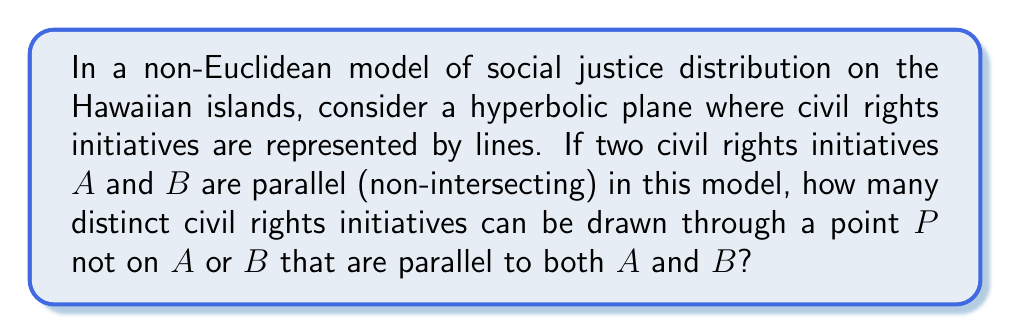Can you answer this question? Let's approach this step-by-step:

1) In Euclidean geometry, the parallel postulate states that through a point not on a given line, there is exactly one line parallel to the given line.

2) However, in hyperbolic geometry, this postulate doesn't hold. Instead, through a point not on a given line, there are infinitely many lines parallel to the given line.

3) In our social justice model, civil rights initiatives are represented as lines in a hyperbolic plane. This means that through any point $P$ not on a given initiative (line) $A$, there are infinitely many initiatives parallel to $A$.

4) Now, we're asked about initiatives parallel to both $A$ and $B$. In hyperbolic geometry, if two lines are parallel, they have a common perpendicular.

5) Let's call the common perpendicular of $A$ and $B$ as line $l$. Point $P$ must lie on one side of $l$.

6) The set of lines through $P$ parallel to $A$ forms a "fan" bounded by two limit rays. The same is true for lines parallel to $B$.

7) The intersection of these two "fans" gives us the set of lines through $P$ parallel to both $A$ and $B$.

8) In hyperbolic geometry, this intersection is always non-empty and consists of infinitely many lines.

[asy]
import geometry;

size(200);

pair A1 = (-5,1), A2 = (5,1);
pair B1 = (-5,-1), B2 = (5,-1);
pair P = (0,3);

draw(A1--A2, blue);
draw(B1--B2, red);
dot(P);

real t = 0.3;
while (t < 1) {
  draw(P--(5,1+2*t), dashed+green);
  t += 0.1;
}

label("$A$", A2, E);
label("$B$", B2, E);
label("$P$", P, N);
[/asy]

Therefore, in this non-Euclidean model of social justice distribution, there are infinitely many distinct civil rights initiatives that can be drawn through point $P$ parallel to both $A$ and $B$.
Answer: Infinitely many 